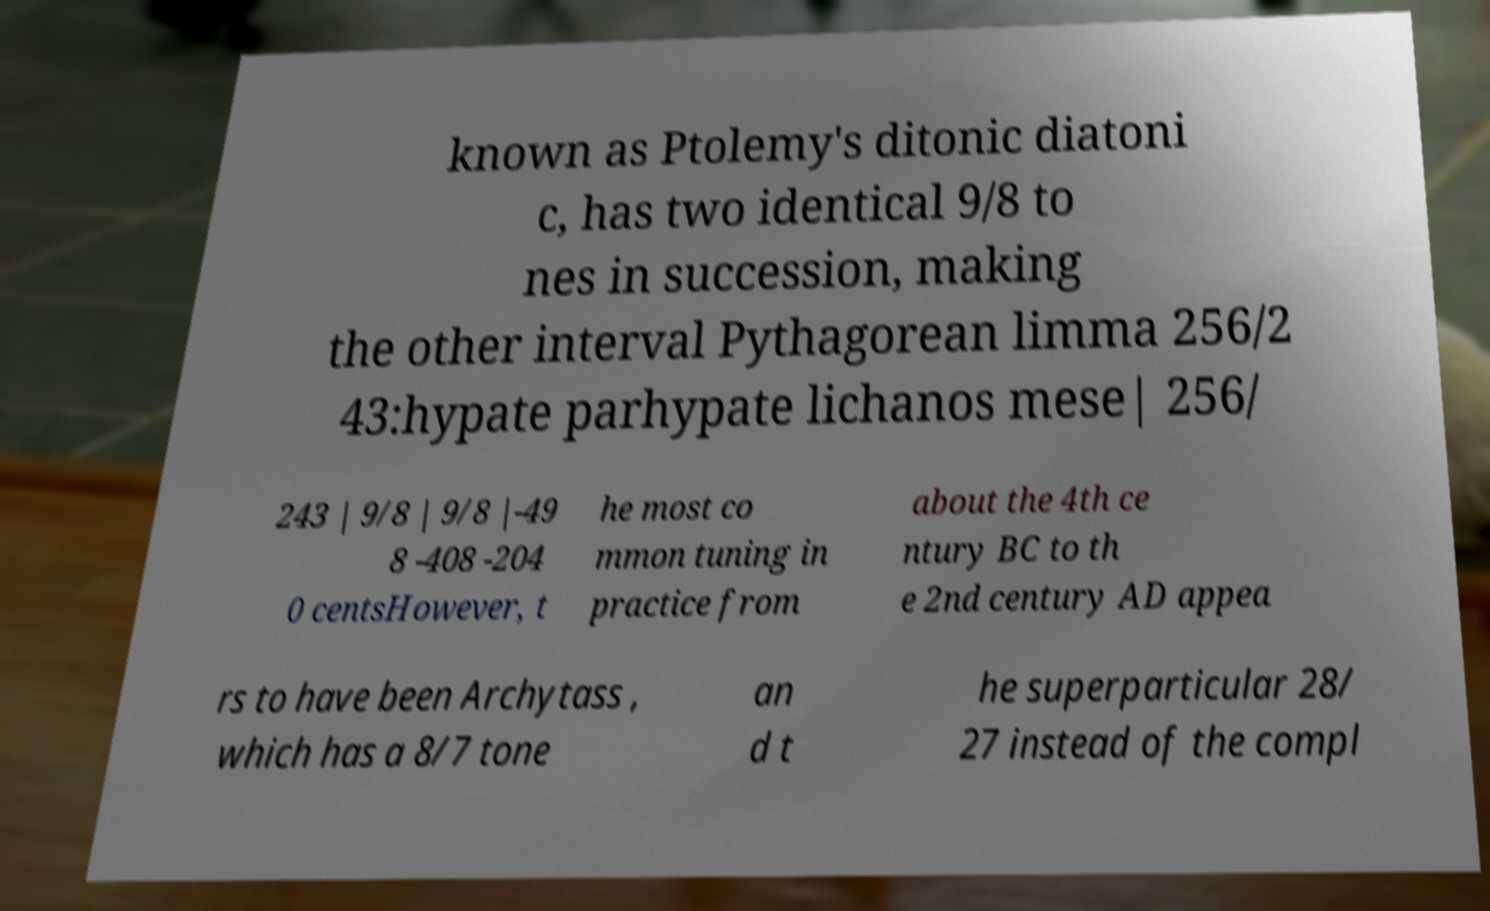Could you assist in decoding the text presented in this image and type it out clearly? known as Ptolemy's ditonic diatoni c, has two identical 9/8 to nes in succession, making the other interval Pythagorean limma 256/2 43:hypate parhypate lichanos mese| 256/ 243 | 9/8 | 9/8 |-49 8 -408 -204 0 centsHowever, t he most co mmon tuning in practice from about the 4th ce ntury BC to th e 2nd century AD appea rs to have been Archytass , which has a 8/7 tone an d t he superparticular 28/ 27 instead of the compl 